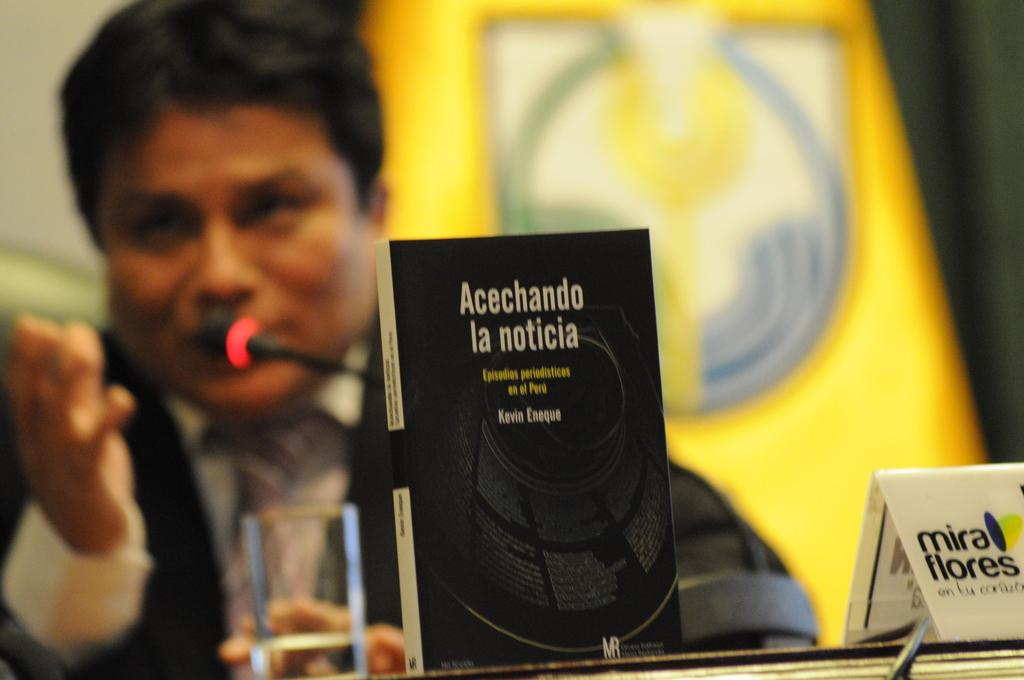What object related to reading can be seen in the image? There is a book in the image. What object related to drinking can be seen in the image? There is a glass in the image. What object related to technology can be seen in the image? There is a cable in the image. What object related to writing or displaying information can be seen in the image? There is a board in the image. How would you describe the background of the image? The background of the image is blurred. Can you identify any human presence in the image? Yes, there is a person in the image. What object related to communication or performance can be seen in the image? There is a microphone (mic) in the image. What object related to advertising can be seen in the image? There is a hoarding in the image. What type of scarf is the person wearing in the image? There is no scarf visible in the image. How many knees can be seen in the image? There is no visible knee in the image. 